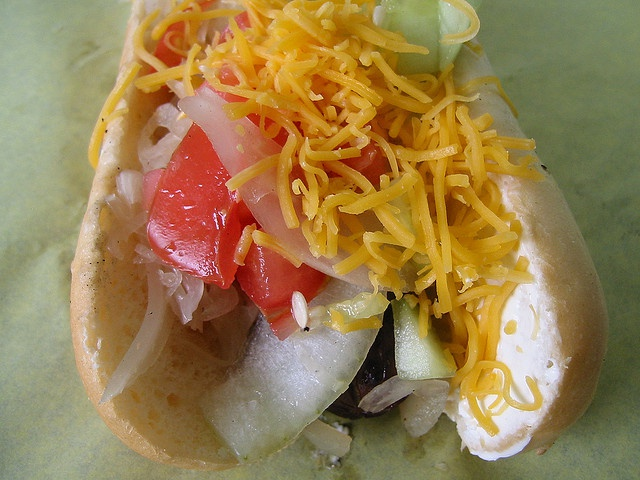Describe the objects in this image and their specific colors. I can see a hot dog in darkgray, olive, orange, tan, and gray tones in this image. 